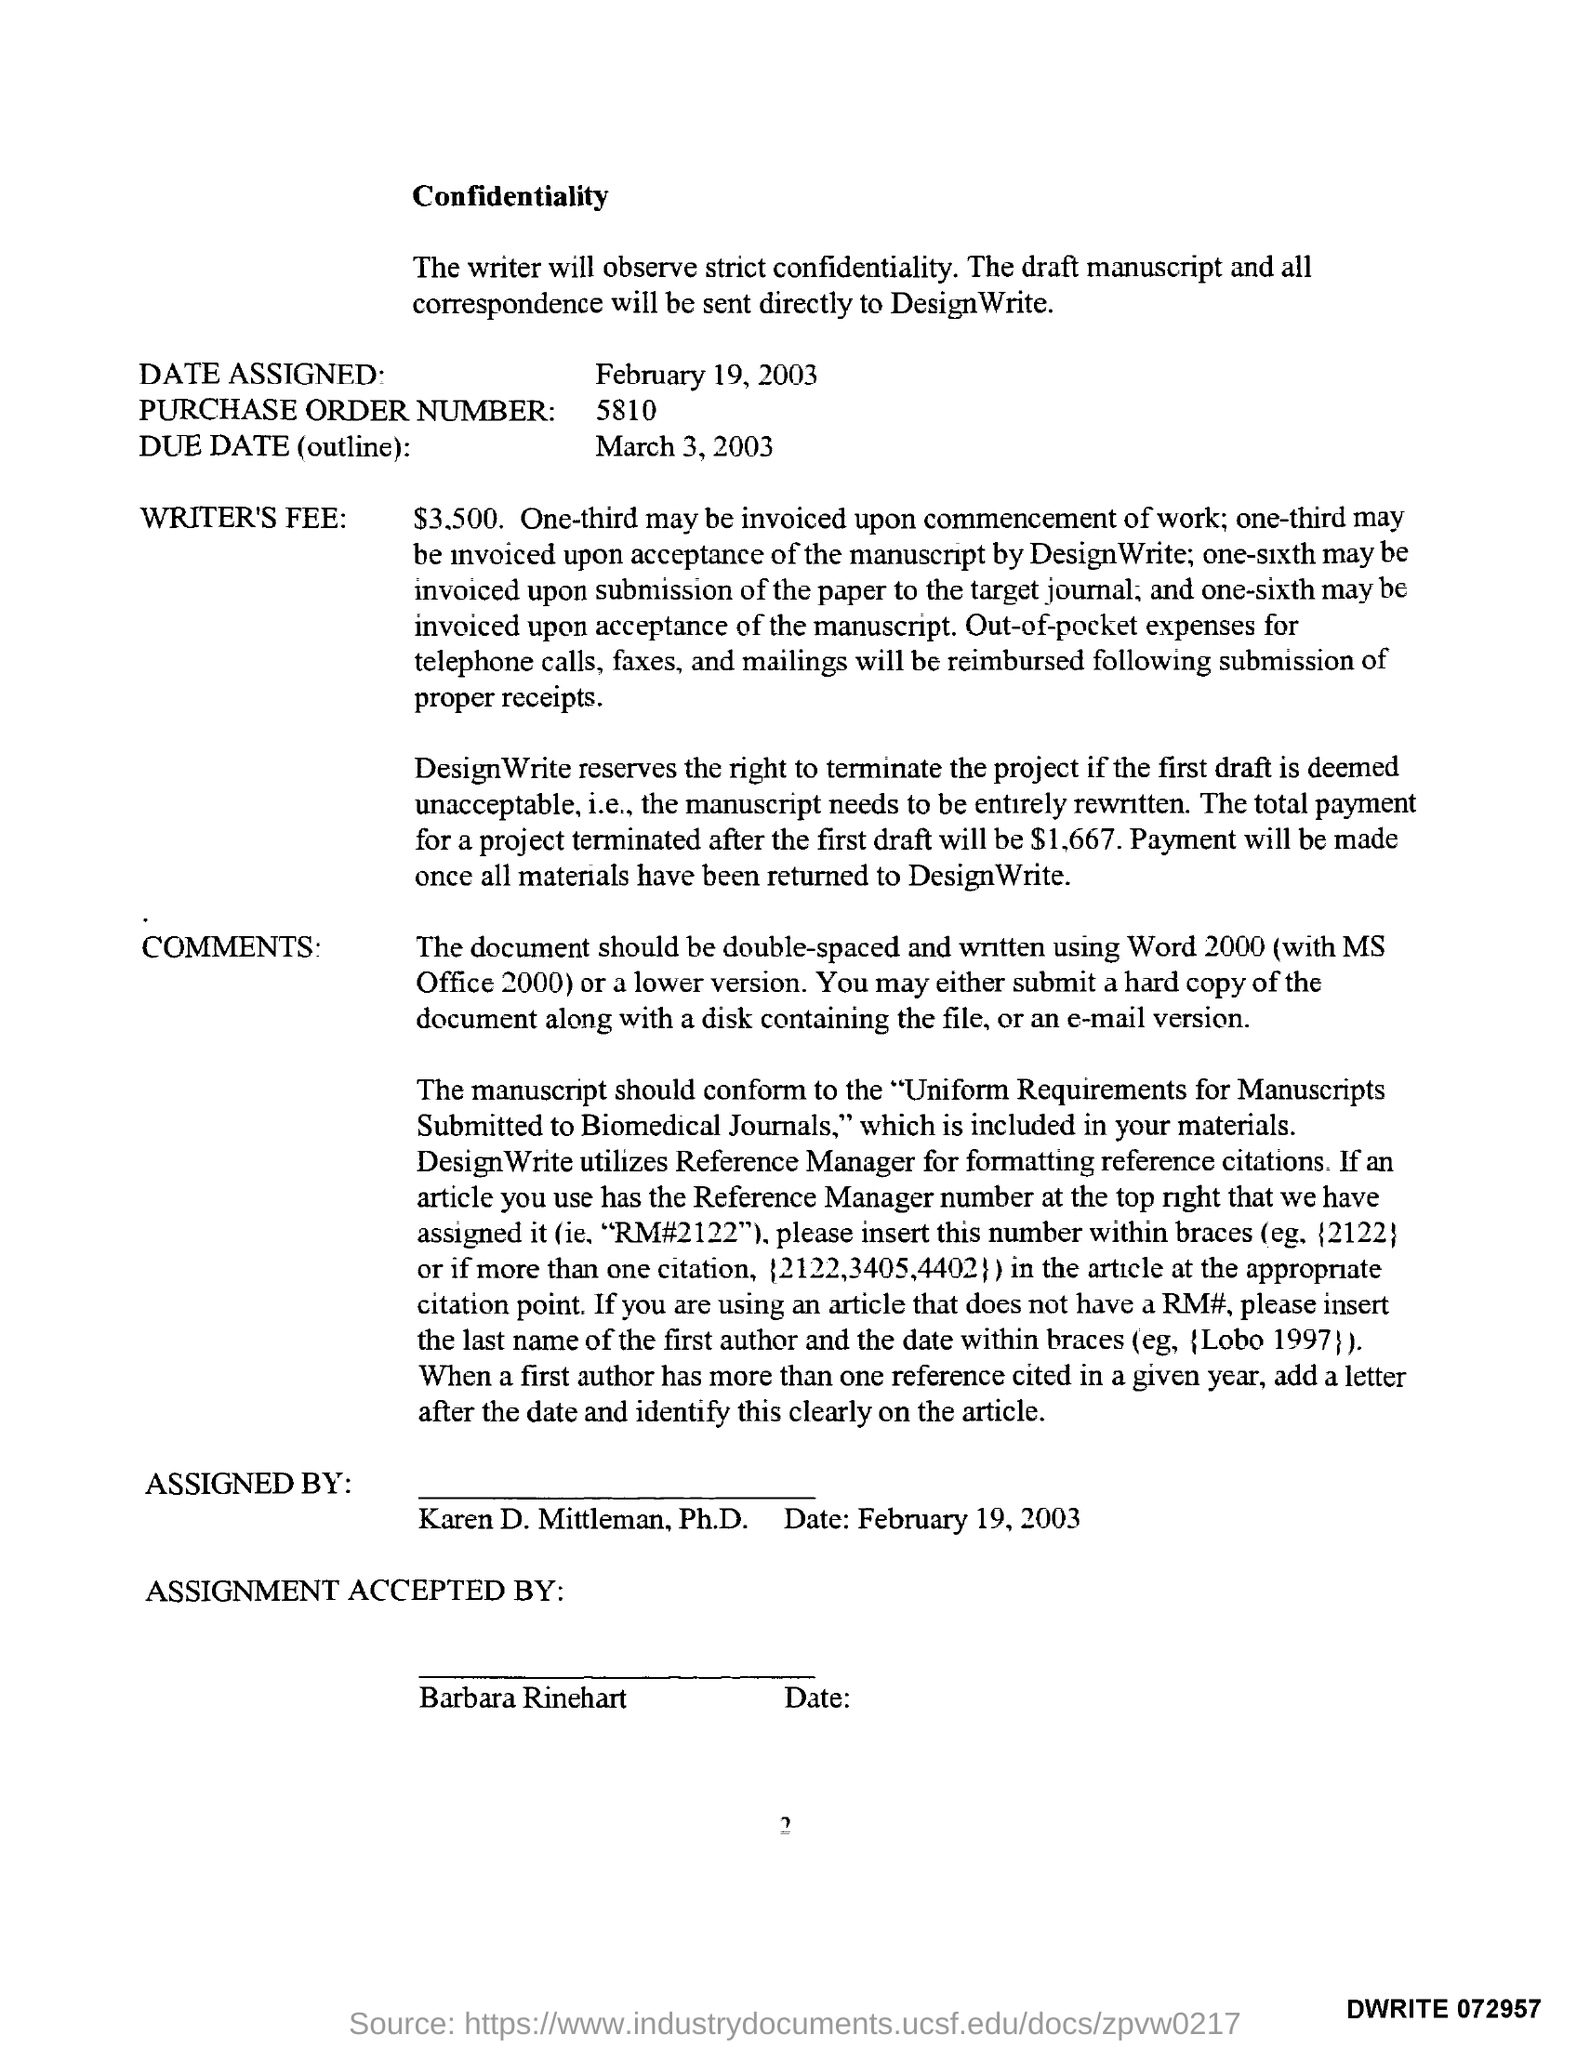What is the purchase order number ?
Ensure brevity in your answer.  5810. What is the due date  (outline)?
Provide a short and direct response. March 3, 2003. Assignment is accepted by whom ?
Ensure brevity in your answer.  Barbara Rinehart. This is assigned by whom ?
Offer a very short reply. Karen D. Mittleman. What  is the total payment for a project terminated after first draft ?
Your answer should be very brief. $1,667. 